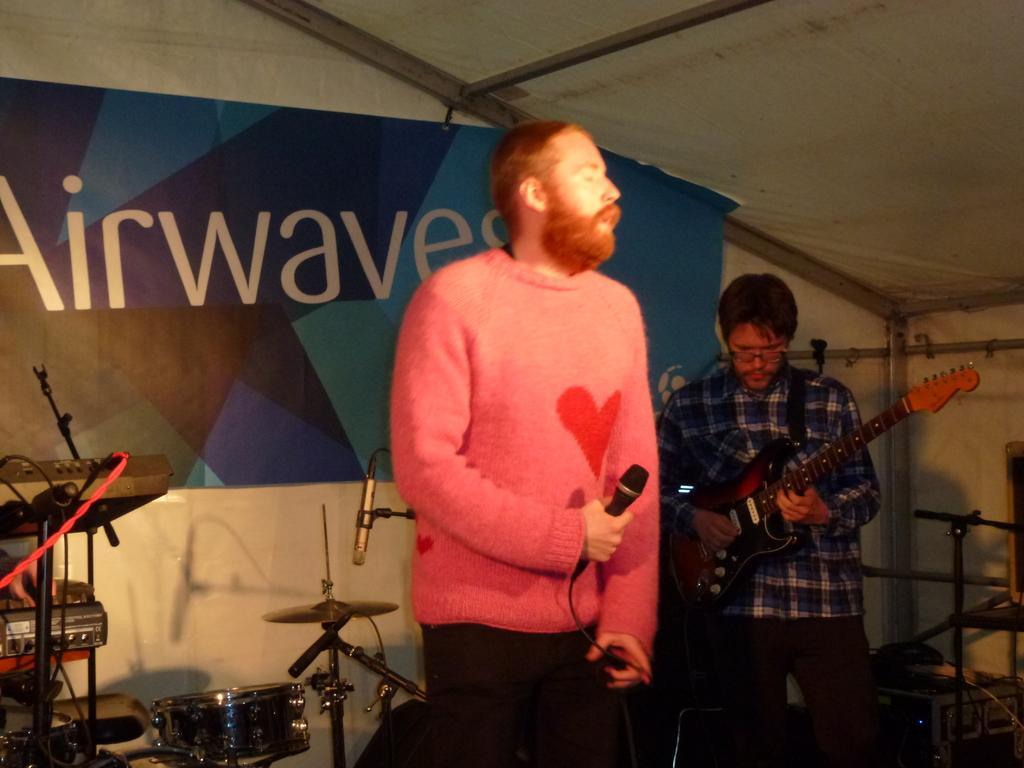Describe this image in one or two sentences. In this image I can see there are two men was standing among them, on the left side of the image the man is wearing a red t-shirt is holding a microphone in his hands and the person on the right side is playing a guitar. 